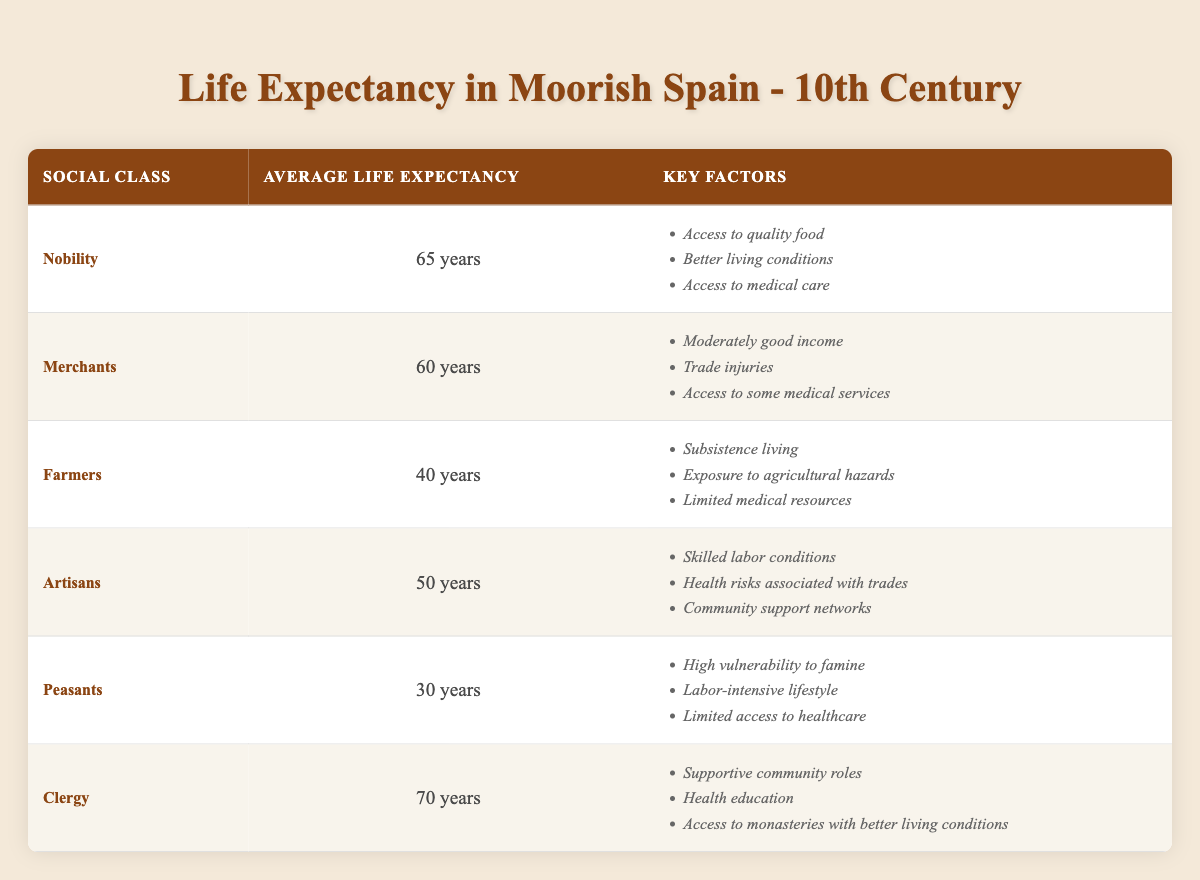What is the average life expectancy of the nobility in the 10th century? The table states that the average life expectancy of the nobility is listed as 65 years. This is a direct retrieval from the data presented.
Answer: 65 years Which social class has the lowest life expectancy? The table indicates that peasants have the lowest life expectancy, recorded at 30 years. This is found by comparing the average life expectancy values across all social classes listed in the table.
Answer: Peasants What is the difference in life expectancy between clergy and farmers? The life expectancy for clergy is noted as 70 years and for farmers, it is 40 years. The difference is calculated by subtracting the farmer's life expectancy from that of the clergy: 70 - 40 = 30 years.
Answer: 30 years Is the average life expectancy for merchants greater than 55 years? According to the table, merchants have an average life expectancy of 60 years. Since 60 is greater than 55, the answer to this question is affirmative.
Answer: Yes What is the average life expectancy of the four classes: farmers, artisans, peasants, and clergy? The average is calculated as follows: (40 + 50 + 30 + 70) / 4. The sum of these values is 190, and dividing this by the four classes gives 190 / 4 = 47.5 years.
Answer: 47.5 years How many social classes have a life expectancy greater than 50 years? Referring to the table, nobility (65), merchants (60), and clergy (70) have life expectancies above 50 years. Counting these classes gives us three social classes, thus the answer is three.
Answer: 3 What are the key factors that contribute to the high life expectancy of the clergy compared to peasants? The clergy enjoys several advantages such as supportive community roles, health education, and access to monasteries with better living conditions. In contrast, peasants face significant risks including high vulnerability to famine, a labor-intensive lifestyle, and limited healthcare access. The disparity in factors illustrates the broader context of health and social structure impacting life expectancy.
Answer: Health benefits of community and education vs. risks of labor and famine Is it true that artisans have a higher life expectancy than farmers? Farmers have a recorded life expectancy of 40 years, while artisans have 50 years. This indicates that artisans indeed have a higher life expectancy compared to farmers, making the answer true.
Answer: Yes 